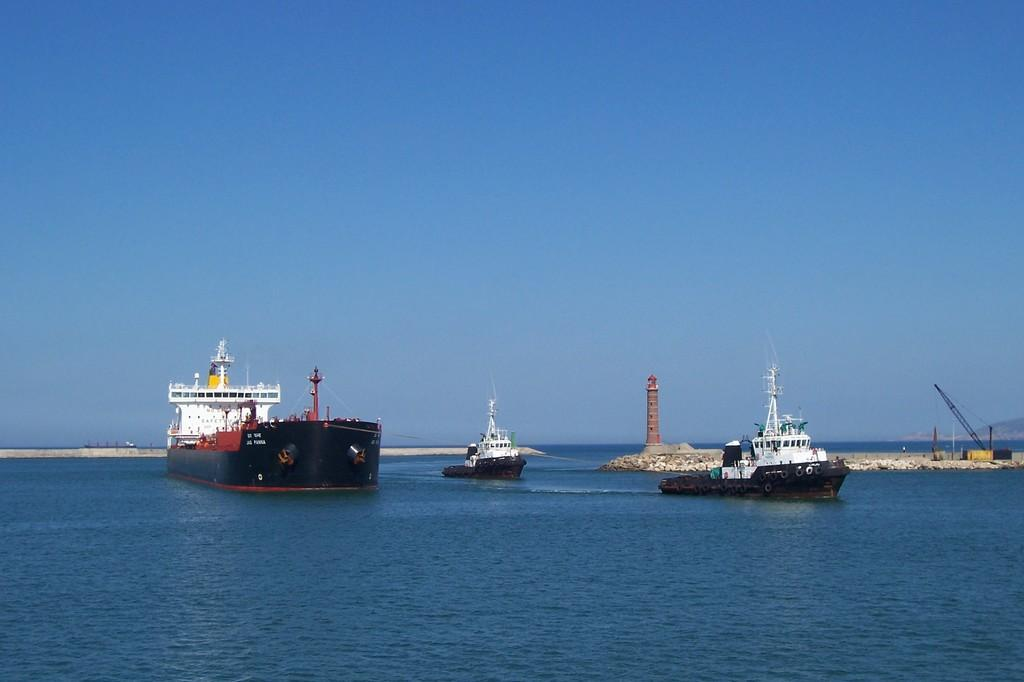What is located in the foreground of the image? There are ships in the foreground of the image. What is the location of the ships in relation to the water? The ships are on the water. What can be seen in the background of the image? There is a lighthouse and other objects in the background of the image. What is visible in the sky in the image? The sky is visible in the background of the image. What type of page is being advertised in the image? There is no page or advertisement present in the image; it features ships, a lighthouse, and other objects. Can you see a tent in the image? There is no tent present in the image. 